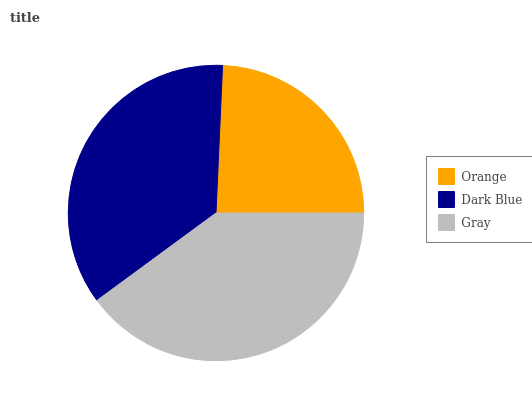Is Orange the minimum?
Answer yes or no. Yes. Is Gray the maximum?
Answer yes or no. Yes. Is Dark Blue the minimum?
Answer yes or no. No. Is Dark Blue the maximum?
Answer yes or no. No. Is Dark Blue greater than Orange?
Answer yes or no. Yes. Is Orange less than Dark Blue?
Answer yes or no. Yes. Is Orange greater than Dark Blue?
Answer yes or no. No. Is Dark Blue less than Orange?
Answer yes or no. No. Is Dark Blue the high median?
Answer yes or no. Yes. Is Dark Blue the low median?
Answer yes or no. Yes. Is Orange the high median?
Answer yes or no. No. Is Orange the low median?
Answer yes or no. No. 